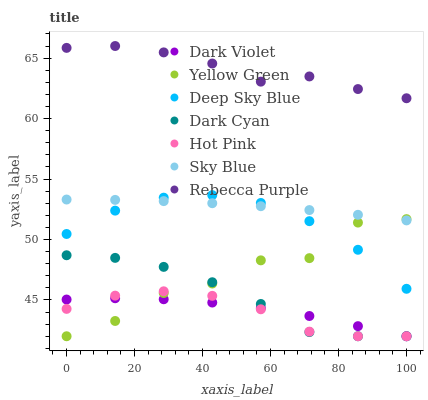Does Hot Pink have the minimum area under the curve?
Answer yes or no. Yes. Does Rebecca Purple have the maximum area under the curve?
Answer yes or no. Yes. Does Dark Violet have the minimum area under the curve?
Answer yes or no. No. Does Dark Violet have the maximum area under the curve?
Answer yes or no. No. Is Sky Blue the smoothest?
Answer yes or no. Yes. Is Yellow Green the roughest?
Answer yes or no. Yes. Is Hot Pink the smoothest?
Answer yes or no. No. Is Hot Pink the roughest?
Answer yes or no. No. Does Yellow Green have the lowest value?
Answer yes or no. Yes. Does Rebecca Purple have the lowest value?
Answer yes or no. No. Does Rebecca Purple have the highest value?
Answer yes or no. Yes. Does Hot Pink have the highest value?
Answer yes or no. No. Is Hot Pink less than Deep Sky Blue?
Answer yes or no. Yes. Is Sky Blue greater than Dark Cyan?
Answer yes or no. Yes. Does Yellow Green intersect Dark Cyan?
Answer yes or no. Yes. Is Yellow Green less than Dark Cyan?
Answer yes or no. No. Is Yellow Green greater than Dark Cyan?
Answer yes or no. No. Does Hot Pink intersect Deep Sky Blue?
Answer yes or no. No. 